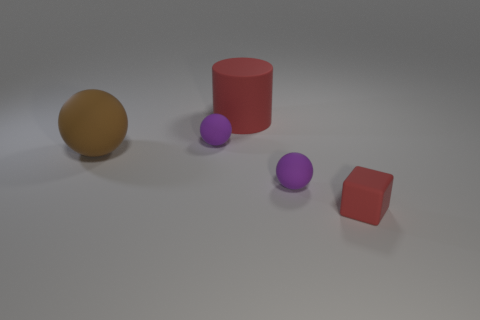The brown sphere that is made of the same material as the large red cylinder is what size?
Your answer should be compact. Large. Is the number of matte objects that are on the right side of the large brown matte sphere greater than the number of matte objects that are in front of the block?
Offer a terse response. Yes. How many other things are there of the same material as the red block?
Your answer should be very brief. 4. The large red object has what shape?
Keep it short and to the point. Cylinder. Is the number of matte objects in front of the brown object greater than the number of matte cubes?
Ensure brevity in your answer.  Yes. Are there any other things that are the same shape as the big red object?
Offer a very short reply. No. There is a red matte thing on the left side of the small matte block; what is its shape?
Offer a very short reply. Cylinder. There is a big brown rubber ball; are there any rubber objects right of it?
Your answer should be compact. Yes. Is there anything else that has the same size as the red rubber cylinder?
Give a very brief answer. Yes. There is a large sphere that is made of the same material as the block; what is its color?
Your response must be concise. Brown. 